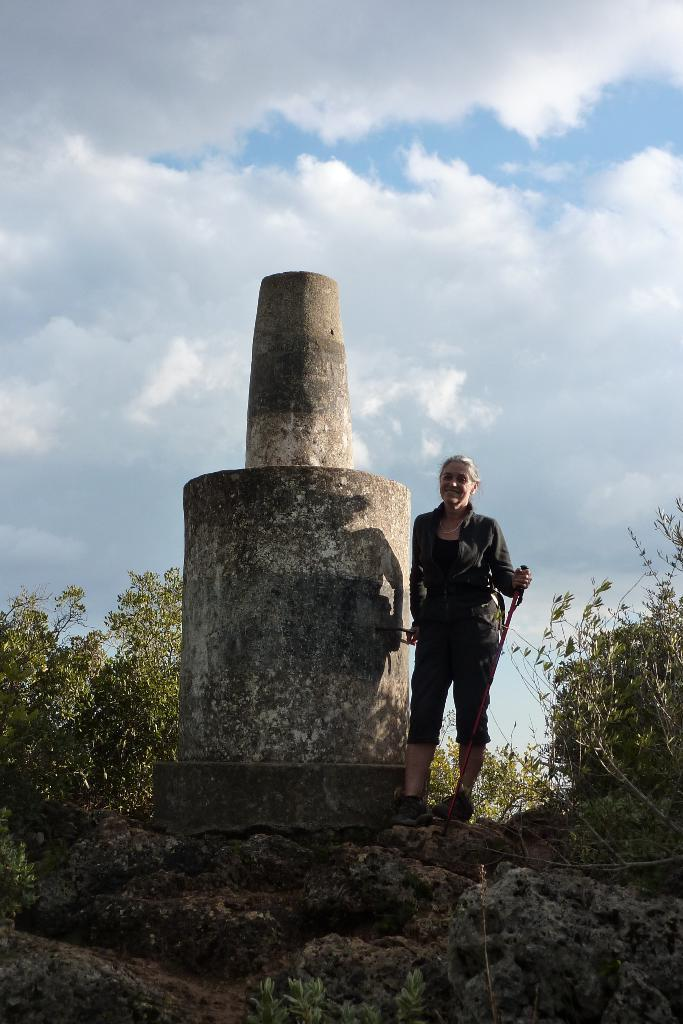Who is present in the image? There is a woman in the image. What is the woman wearing? The woman is wearing a black dress. What is the woman standing beside? The woman is standing beside a statue. What can be seen on either side of the statue? There are plants on either side of the statue. What is visible in the background of the image? The sky is visible in the image, and clouds are present in the sky. What type of advertisement can be seen on the woman's dress in the image? There is no advertisement present on the woman's dress in the image. 